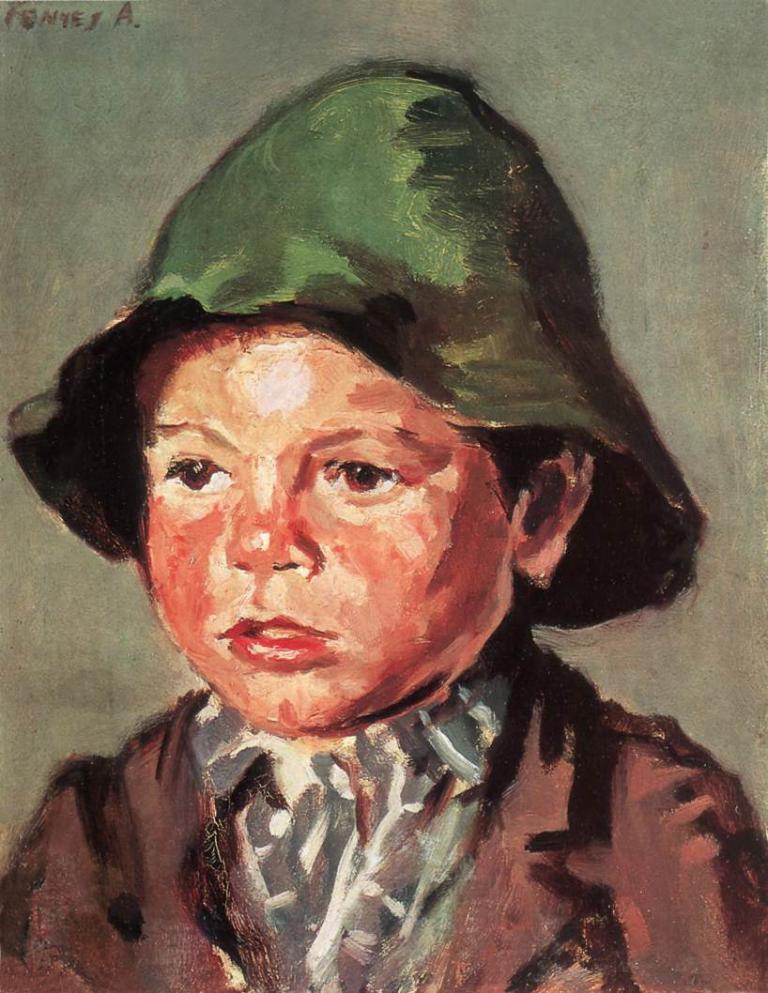Can you describe this image briefly? In this image we can see a painting of a person. Person wore a cap. At the top left side of the image there is a watermark.   